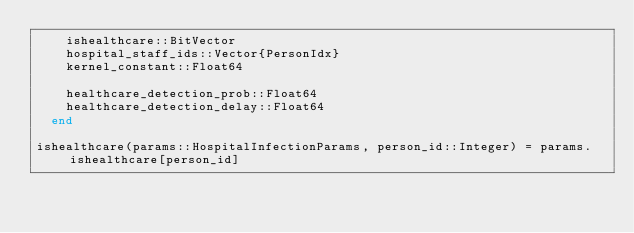Convert code to text. <code><loc_0><loc_0><loc_500><loc_500><_Julia_>    ishealthcare::BitVector
    hospital_staff_ids::Vector{PersonIdx}
    kernel_constant::Float64

    healthcare_detection_prob::Float64
    healthcare_detection_delay::Float64
  end

ishealthcare(params::HospitalInfectionParams, person_id::Integer) = params.ishealthcare[person_id]
</code> 